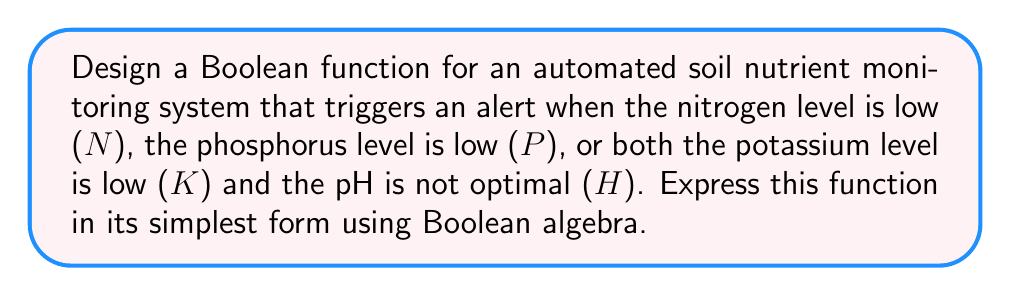Teach me how to tackle this problem. Let's approach this step-by-step:

1) First, we define our variables:
   N: Nitrogen level is low (1 if true, 0 if false)
   P: Phosphorus level is low (1 if true, 0 if false)
   K: Potassium level is low (1 if true, 0 if false)
   H: pH is not optimal (1 if true, 0 if false)

2) The alert should trigger when:
   - Nitrogen is low (N), OR
   - Phosphorus is low (P), OR
   - Both Potassium is low AND pH is not optimal (K ∧ H)

3) We can express this as a Boolean function:

   $$F = N \lor P \lor (K \land H)$$

4) This function is already in its simplest form, as it uses the fundamental operations (OR and AND) and cannot be further reduced using Boolean algebra laws.

5) In terms of implementation, this function could be easily translated into a programming language for the soil monitoring system:

   ```
   if (N OR P OR (K AND H)) then
       trigger_alert()
   end if
   ```

This Boolean function allows for an efficient and accurate representation of the conditions that should trigger an alert in the soil nutrient monitoring system.
Answer: $$N \lor P \lor (K \land H)$$ 